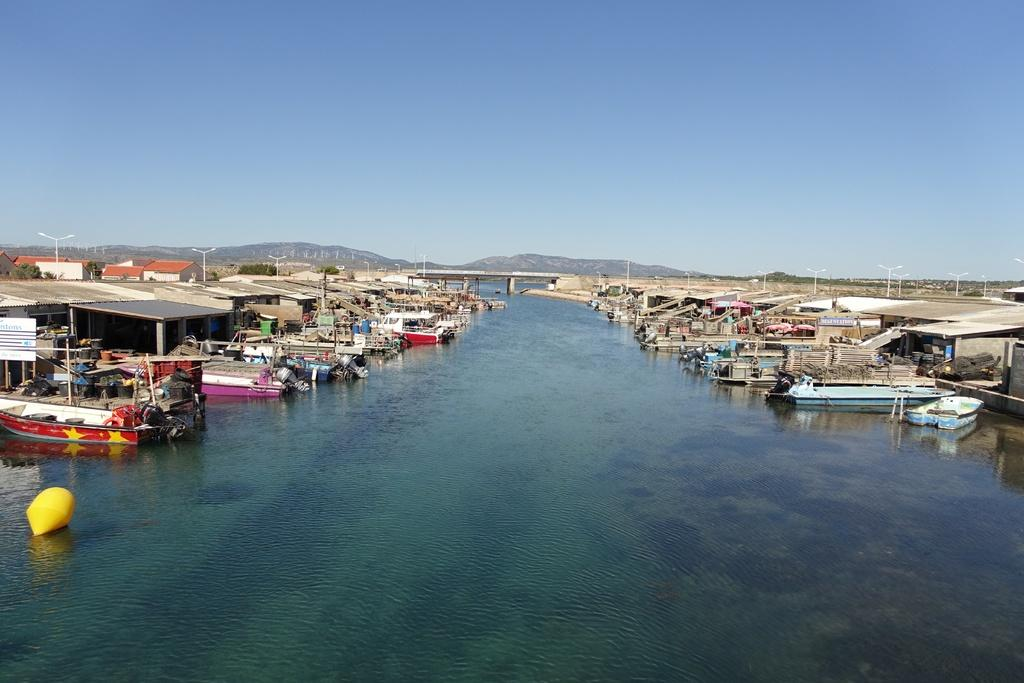What is in the foreground of the image? There is a water surface in the foreground of the image. What is on the water surface? There are boats on the water surface. What can be seen in the background of the image? There are houses, poles, mountains, and the sky visible in the background of the image. What type of glove is being used to take the picture in the image? There is no camera or glove present in the image; it is a scene of boats on a water surface with houses, poles, mountains, and the sky in the background. 